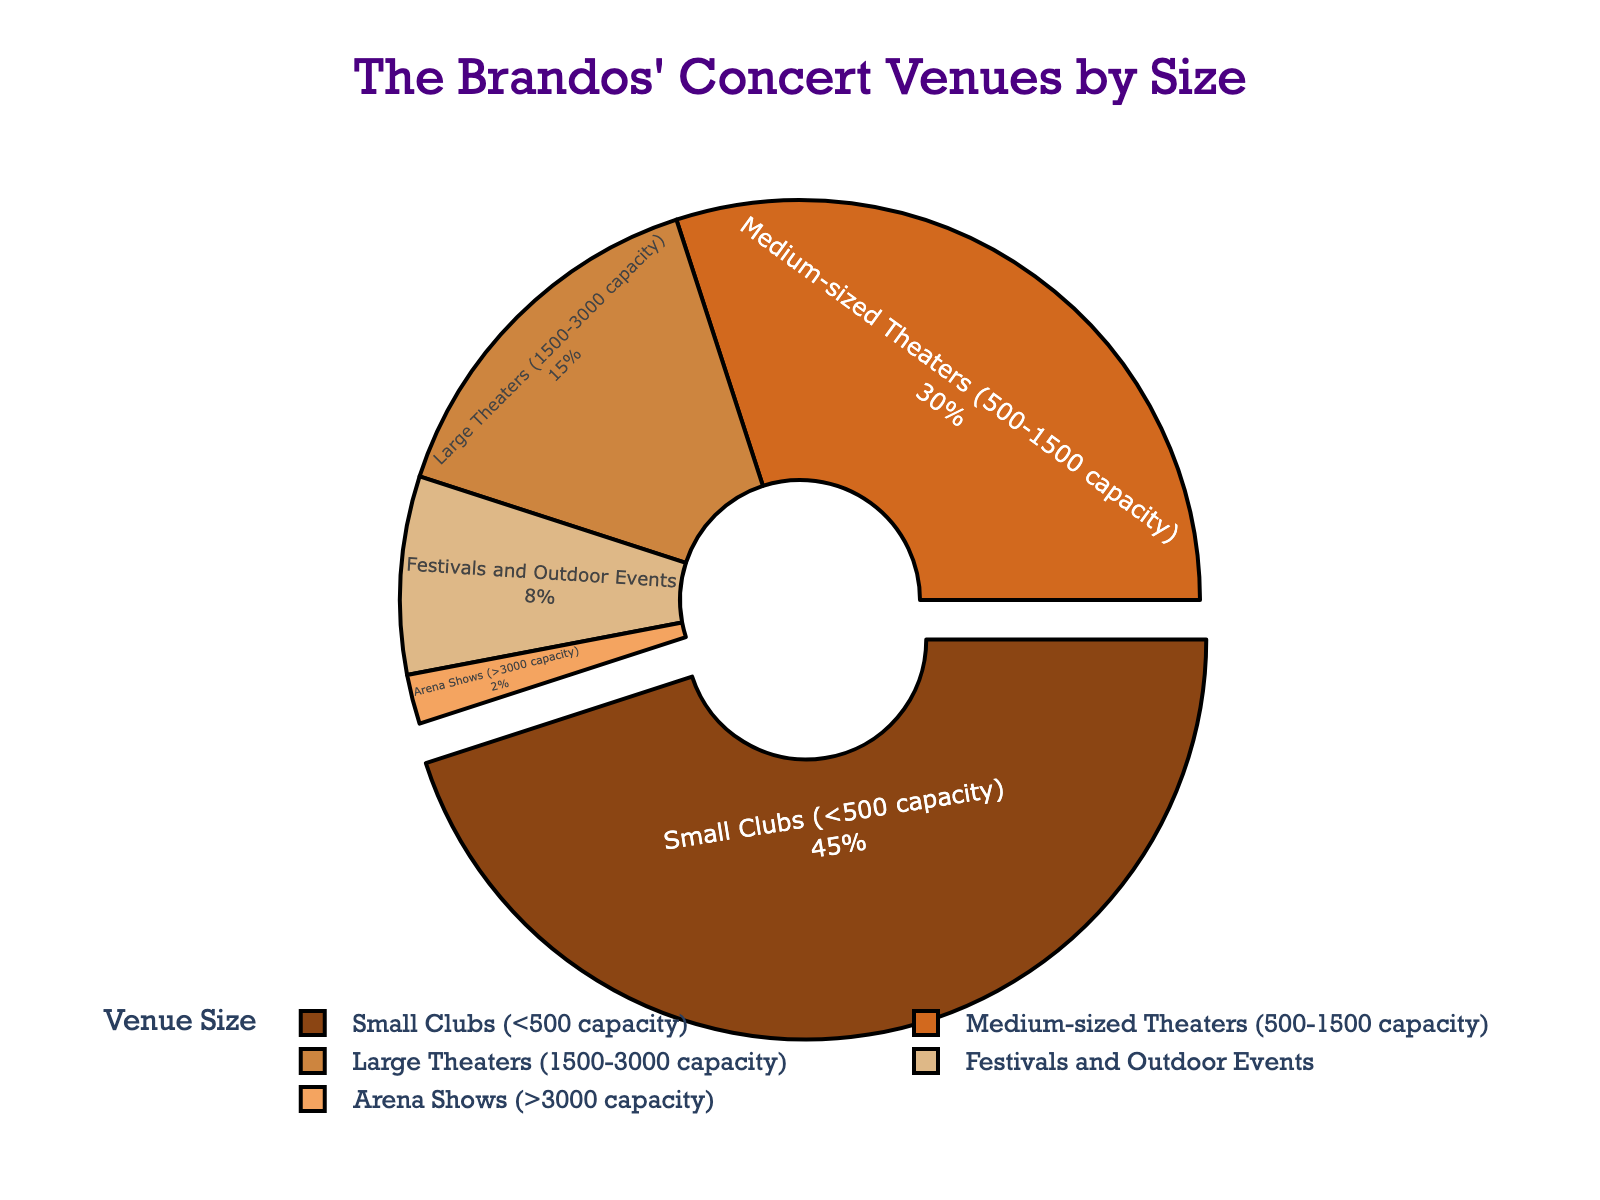What percentage of The Brandos' concert venues are large theaters or bigger? The "Large Theaters" category has 15%, "Festivals and Outdoor Events" have 8%, and "Arena Shows" have 2%, so adding 15% + 8% + 2% gives a total of 25%.
Answer: 25% Which type of venue has the smallest percentage and what is it? The "Arena Shows" category has the smallest percentage, which is 2%.
Answer: Arena Shows, 2% Are there more small clubs or medium-sized theaters in The Brandos' concert venues? The "Small Clubs" category accounts for 45% and the "Medium-sized Theaters" category accounts for 30%. Since 45% is greater than 30%, there are more small clubs.
Answer: Small Clubs What is the combined percentage for small clubs and medium-sized theaters? The "Small Clubs" category is 45% and the "Medium-sized Theaters" category is 30%. Adding 45% + 30% gives a combined total of 75%.
Answer: 75% How does the percentage of festivals and outdoor events compare to that of large theaters? The "Festivals and Outdoor Events" category is 8% while the "Large Theaters" category is 15%. Since 8% is less than 15%, festivals and outdoor events have a smaller percentage.
Answer: Less than Which category is visually emphasized by being slightly pulled out from the pie chart? The "Small Clubs" category is visually emphasized by being slightly pulled out from the pie chart.
Answer: Small Clubs What visual element denotes the differences between the size categories in the pie chart? The pie chart uses different colors to denote the differences between the size categories.
Answer: Colors What percentage of The Brandos' concert venues are neither the smallest nor the largest categories? The "Arena Shows" (2%) and "Small Clubs" (45%) are the smallest and largest categories. The remaining categories are "Medium-sized Theaters" (30%), "Large Theaters" (15%), and "Festivals and Outdoor Events" (8%). Summing these gives 30% + 15% + 8% = 53%.
Answer: 53% How much more common are small clubs compared to arena shows in terms of percentage? The "Small Clubs" category is 45% and the "Arena Shows" category is 2%. Subtracting 2% from 45% gives 45% - 2% = 43%.
Answer: 43% What is the average percentage for large theaters, festivals and outdoor events, and arena shows? The percentages are 15%, 8%, and 2% for "Large Theaters," "Festivals and Outdoor Events," and "Arena Shows," respectively. Adding them gives 15% + 8% + 2% = 25%, and the average is 25% / 3 ≈ 8.33%.
Answer: 8.33% 